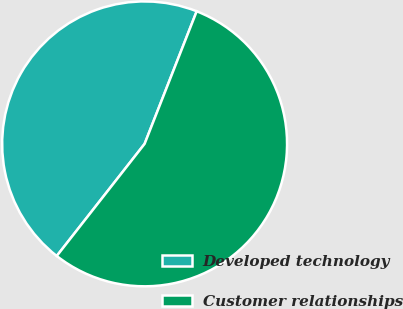Convert chart to OTSL. <chart><loc_0><loc_0><loc_500><loc_500><pie_chart><fcel>Developed technology<fcel>Customer relationships<nl><fcel>45.38%<fcel>54.62%<nl></chart> 